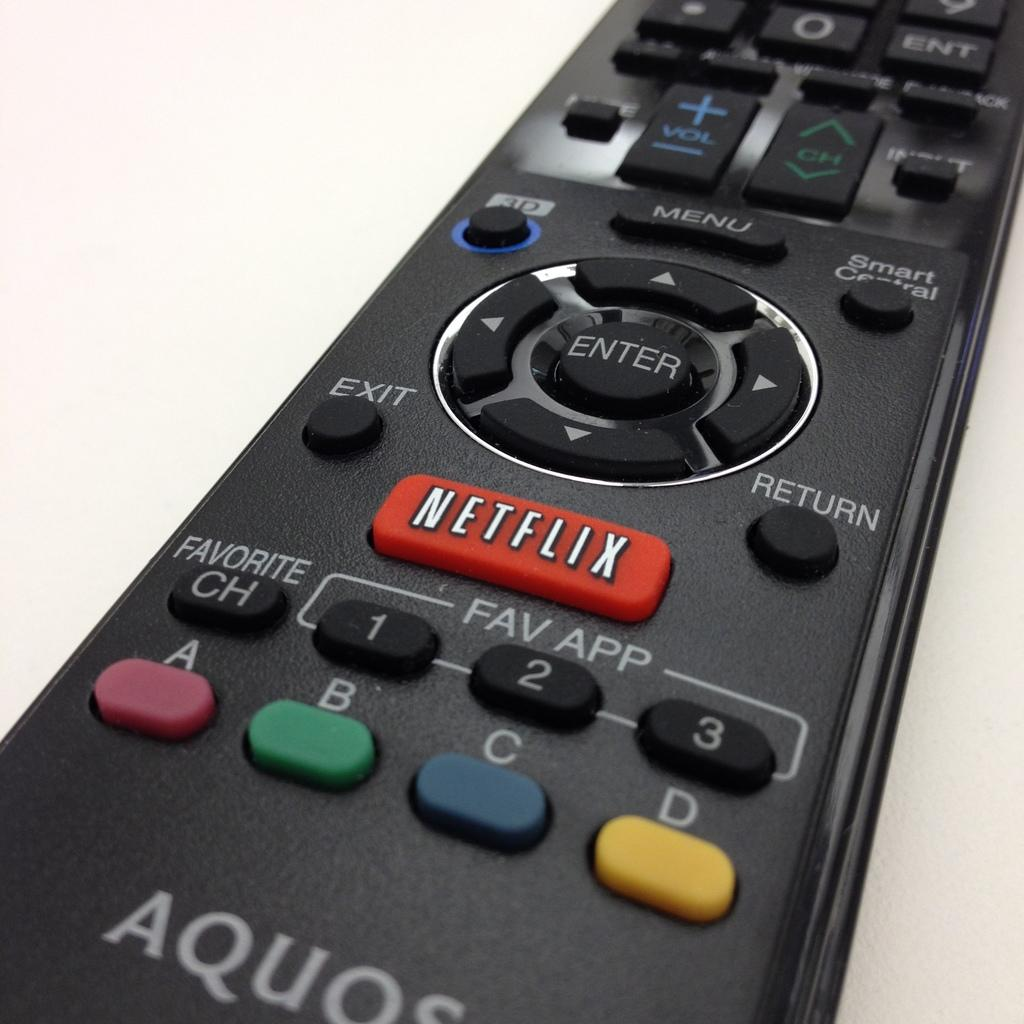Provide a one-sentence caption for the provided image. An Aquos, black, remote control containing different buttons including Netflix, Favorite, Menu, Enter and more. 